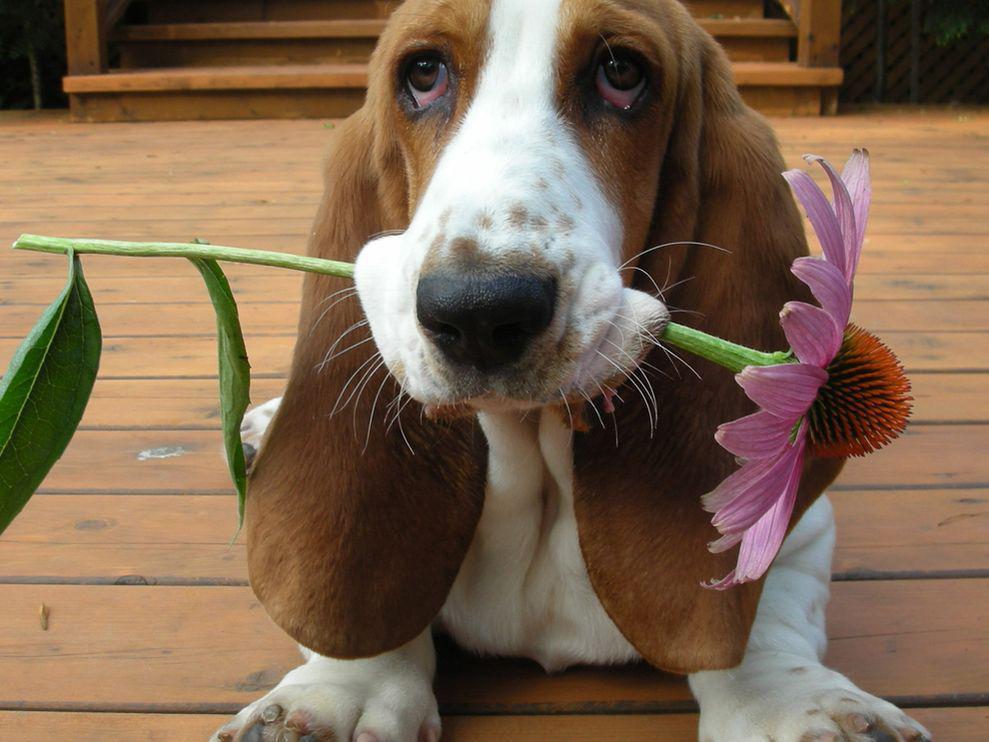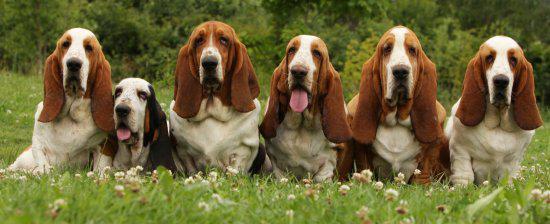The first image is the image on the left, the second image is the image on the right. Evaluate the accuracy of this statement regarding the images: "The image contains a dog with something in his mouth". Is it true? Answer yes or no. Yes. The first image is the image on the left, the second image is the image on the right. Examine the images to the left and right. Is the description "There are no more than two dogs." accurate? Answer yes or no. No. 